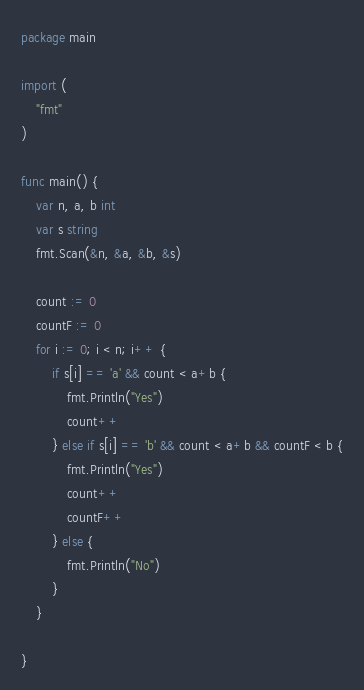Convert code to text. <code><loc_0><loc_0><loc_500><loc_500><_Go_>package main

import (
	"fmt"
)

func main() {
	var n, a, b int
	var s string
	fmt.Scan(&n, &a, &b, &s)

	count := 0
	countF := 0
	for i := 0; i < n; i++ {
		if s[i] == 'a' && count < a+b {
			fmt.Println("Yes")
			count++
		} else if s[i] == 'b' && count < a+b && countF < b {
			fmt.Println("Yes")
			count++
			countF++
		} else {
			fmt.Println("No")
		}
	}

}
</code> 